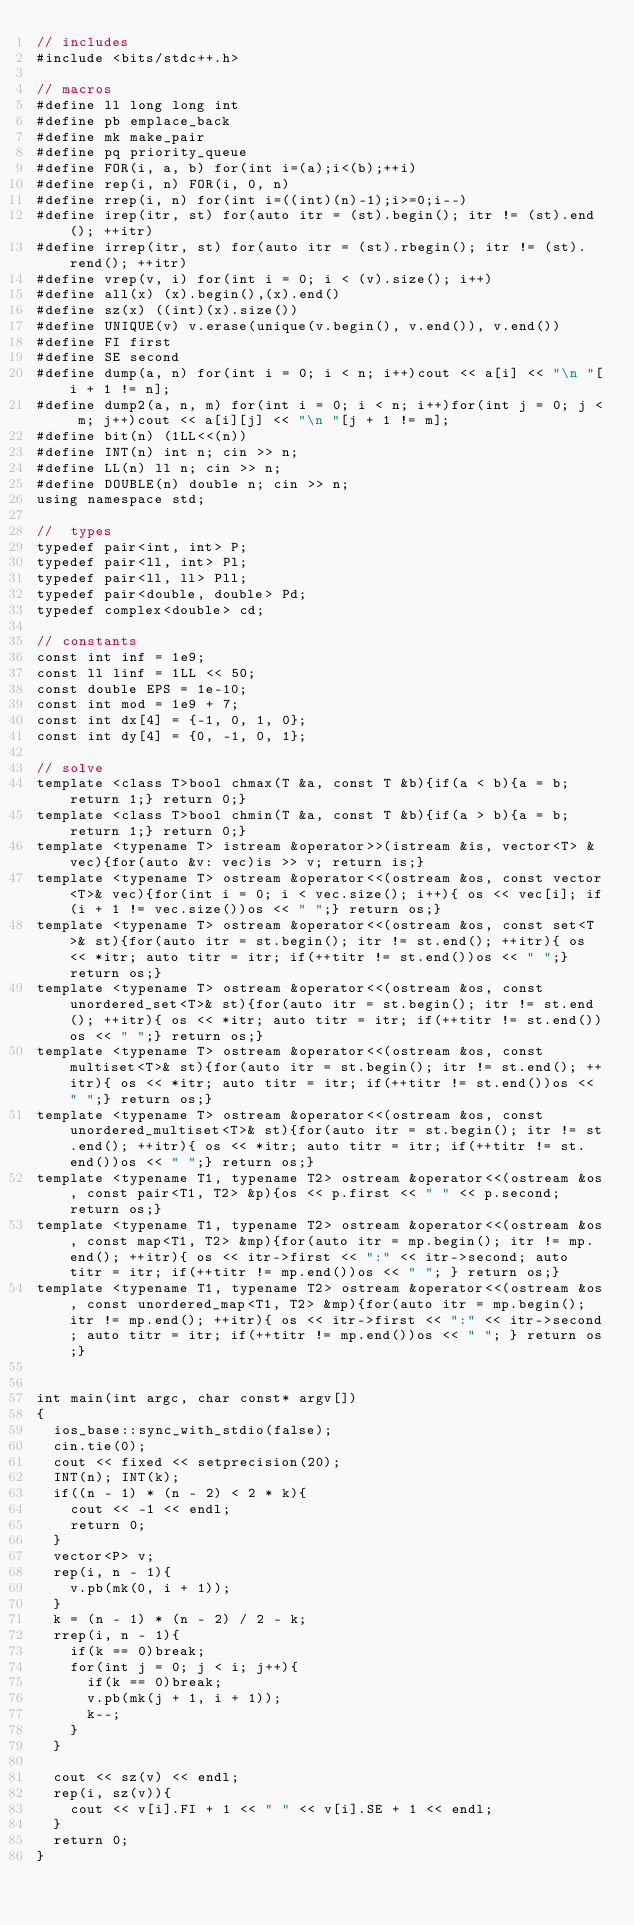Convert code to text. <code><loc_0><loc_0><loc_500><loc_500><_C++_>// includes
#include <bits/stdc++.h>

// macros
#define ll long long int
#define pb emplace_back
#define mk make_pair
#define pq priority_queue
#define FOR(i, a, b) for(int i=(a);i<(b);++i)
#define rep(i, n) FOR(i, 0, n)
#define rrep(i, n) for(int i=((int)(n)-1);i>=0;i--)
#define irep(itr, st) for(auto itr = (st).begin(); itr != (st).end(); ++itr)
#define irrep(itr, st) for(auto itr = (st).rbegin(); itr != (st).rend(); ++itr)
#define vrep(v, i) for(int i = 0; i < (v).size(); i++)
#define all(x) (x).begin(),(x).end()
#define sz(x) ((int)(x).size())
#define UNIQUE(v) v.erase(unique(v.begin(), v.end()), v.end())
#define FI first
#define SE second
#define dump(a, n) for(int i = 0; i < n; i++)cout << a[i] << "\n "[i + 1 != n];
#define dump2(a, n, m) for(int i = 0; i < n; i++)for(int j = 0; j < m; j++)cout << a[i][j] << "\n "[j + 1 != m];
#define bit(n) (1LL<<(n))
#define INT(n) int n; cin >> n;
#define LL(n) ll n; cin >> n;
#define DOUBLE(n) double n; cin >> n;
using namespace std;

//  types
typedef pair<int, int> P;
typedef pair<ll, int> Pl;
typedef pair<ll, ll> Pll;
typedef pair<double, double> Pd;
typedef complex<double> cd;
 
// constants
const int inf = 1e9;
const ll linf = 1LL << 50;
const double EPS = 1e-10;
const int mod = 1e9 + 7;
const int dx[4] = {-1, 0, 1, 0};
const int dy[4] = {0, -1, 0, 1};

// solve
template <class T>bool chmax(T &a, const T &b){if(a < b){a = b; return 1;} return 0;}
template <class T>bool chmin(T &a, const T &b){if(a > b){a = b; return 1;} return 0;}
template <typename T> istream &operator>>(istream &is, vector<T> &vec){for(auto &v: vec)is >> v; return is;}
template <typename T> ostream &operator<<(ostream &os, const vector<T>& vec){for(int i = 0; i < vec.size(); i++){ os << vec[i]; if(i + 1 != vec.size())os << " ";} return os;}
template <typename T> ostream &operator<<(ostream &os, const set<T>& st){for(auto itr = st.begin(); itr != st.end(); ++itr){ os << *itr; auto titr = itr; if(++titr != st.end())os << " ";} return os;}
template <typename T> ostream &operator<<(ostream &os, const unordered_set<T>& st){for(auto itr = st.begin(); itr != st.end(); ++itr){ os << *itr; auto titr = itr; if(++titr != st.end())os << " ";} return os;}
template <typename T> ostream &operator<<(ostream &os, const multiset<T>& st){for(auto itr = st.begin(); itr != st.end(); ++itr){ os << *itr; auto titr = itr; if(++titr != st.end())os << " ";} return os;}
template <typename T> ostream &operator<<(ostream &os, const unordered_multiset<T>& st){for(auto itr = st.begin(); itr != st.end(); ++itr){ os << *itr; auto titr = itr; if(++titr != st.end())os << " ";} return os;}
template <typename T1, typename T2> ostream &operator<<(ostream &os, const pair<T1, T2> &p){os << p.first << " " << p.second; return os;}
template <typename T1, typename T2> ostream &operator<<(ostream &os, const map<T1, T2> &mp){for(auto itr = mp.begin(); itr != mp.end(); ++itr){ os << itr->first << ":" << itr->second; auto titr = itr; if(++titr != mp.end())os << " "; } return os;}
template <typename T1, typename T2> ostream &operator<<(ostream &os, const unordered_map<T1, T2> &mp){for(auto itr = mp.begin(); itr != mp.end(); ++itr){ os << itr->first << ":" << itr->second; auto titr = itr; if(++titr != mp.end())os << " "; } return os;}


int main(int argc, char const* argv[])
{
  ios_base::sync_with_stdio(false);
  cin.tie(0);
  cout << fixed << setprecision(20);
  INT(n); INT(k);
  if((n - 1) * (n - 2) < 2 * k){
  	cout << -1 << endl;
  	return 0;
  }
  vector<P> v;
  rep(i, n - 1){
  	v.pb(mk(0, i + 1));
  }
  k = (n - 1) * (n - 2) / 2 - k;
  rrep(i, n - 1){
  	if(k == 0)break;
  	for(int j = 0; j < i; j++){
	  	if(k == 0)break;
  		v.pb(mk(j + 1, i + 1));
  		k--;
  	}
  }

  cout << sz(v) << endl;
  rep(i, sz(v)){
  	cout << v[i].FI + 1 << " " << v[i].SE + 1 << endl;
  }
  return 0;
}</code> 